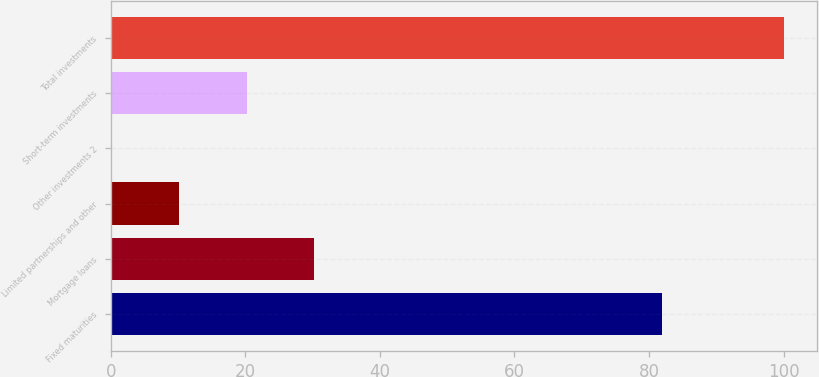Convert chart. <chart><loc_0><loc_0><loc_500><loc_500><bar_chart><fcel>Fixed maturities<fcel>Mortgage loans<fcel>Limited partnerships and other<fcel>Other investments 2<fcel>Short-term investments<fcel>Total investments<nl><fcel>81.9<fcel>30.14<fcel>10.18<fcel>0.2<fcel>20.16<fcel>100<nl></chart> 